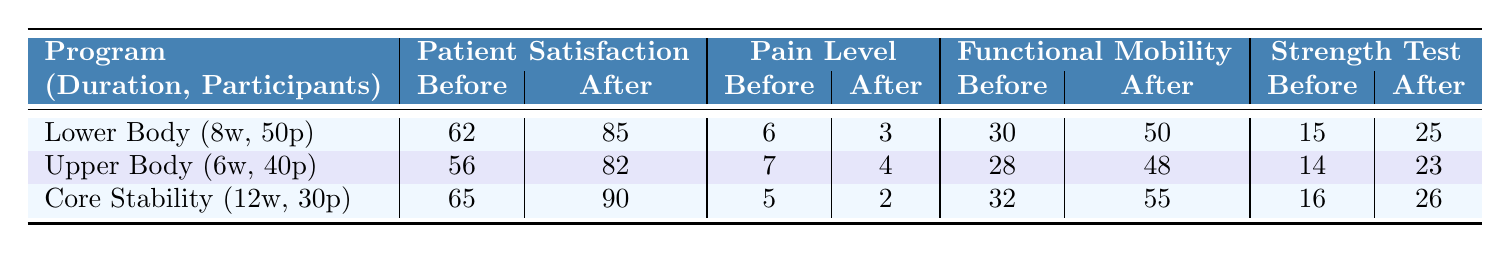What is the increase in patient satisfaction for the Lower Body Strengthening program? The patient satisfaction score increased from 62 (Before) to 85 (After). Thus, the increase is 85 - 62 = 23.
Answer: 23 What was the Pain Level score after the Core Stability Training program? The Pain Level score after the Core Stability Training program is 2 (After).
Answer: 2 Which strength training program had the highest Functional Mobility Score before the training? The Functional Mobility Score before the training for each program is as follows: Lower Body (30), Upper Body (28), and Core Stability (32). The highest score is 32 for the Core Stability program.
Answer: Core Stability What is the average increase in Strength Test Scores across all three programs? The increases in Strength Test Scores are: Lower Body (10), Upper Body (9), and Core Stability (10). Their total is 10 + 9 + 10 = 29. There are 3 programs, so the average increase is 29 / 3 = 9.67.
Answer: 9.67 Did the Upper Body Strengthening program result in more pain after the training compared to before? The Pain Level score before was 7, and after it was 4. Since 4 is less than 7, it resulted in less pain after the training.
Answer: No Which program had the greatest reduction in Pain Level? For each program, the reductions are: Lower Body (6 - 3 = 3), Upper Body (7 - 4 = 3), and Core Stability (5 - 2 = 3). All programs had the same reduction of 3.
Answer: All programs What is the percentage increase in patient satisfaction for the Upper Body Strengthening program? The patient satisfaction increased from 56 to 82. The increase is 82 - 56 = 26. The percentage increase is (26 / 56) * 100% = 46.43%.
Answer: 46.43% Which program had the highest number of participants? The number of participants in each program is: Lower Body (50), Upper Body (40), and Core Stability (30). The highest number is 50 from the Lower Body Strengthening program.
Answer: Lower Body What can be concluded about the relationship between the duration of the programs and the outcomes regarding patient satisfaction? The durations of the programs are: Lower Body (8 weeks), Upper Body (6 weeks), and Core Stability (12 weeks). The rankings for patient satisfaction increases are: Lower Body (23), Upper Body (26), and Core Stability (25). The trend shows that the program with the longest duration (Core Stability) does not have the highest satisfaction increase. Thus, duration doesn't directly correlates with patient satisfaction.
Answer: Duration does not directly correlate with satisfaction 